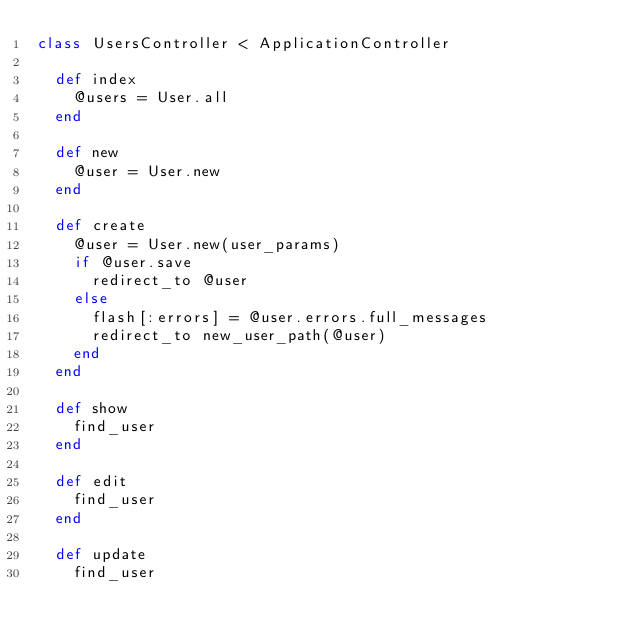Convert code to text. <code><loc_0><loc_0><loc_500><loc_500><_Ruby_>class UsersController < ApplicationController

  def index
    @users = User.all
  end

  def new
    @user = User.new
  end

  def create
    @user = User.new(user_params)
    if @user.save
      redirect_to @user
    else
      flash[:errors] = @user.errors.full_messages
      redirect_to new_user_path(@user)
    end
  end

  def show
    find_user
  end

  def edit
    find_user
  end

  def update
    find_user</code> 